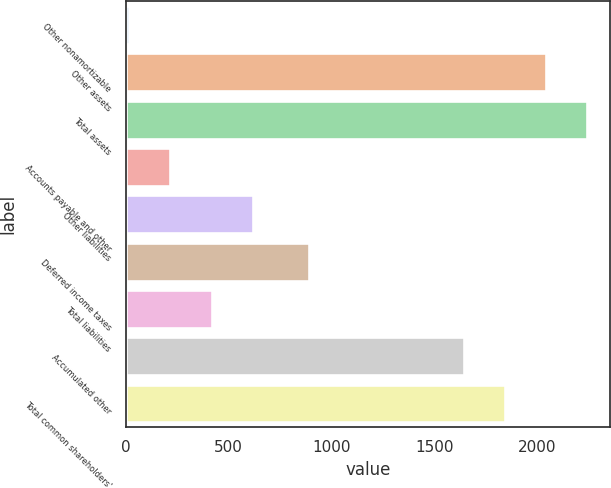<chart> <loc_0><loc_0><loc_500><loc_500><bar_chart><fcel>Other nonamortizable<fcel>Other assets<fcel>Total assets<fcel>Accounts payable and other<fcel>Other liabilities<fcel>Deferred income taxes<fcel>Total liabilities<fcel>Accumulated other<fcel>Total common shareholders'<nl><fcel>17<fcel>2042.8<fcel>2242.7<fcel>216.9<fcel>616.7<fcel>891<fcel>416.8<fcel>1643<fcel>1842.9<nl></chart> 